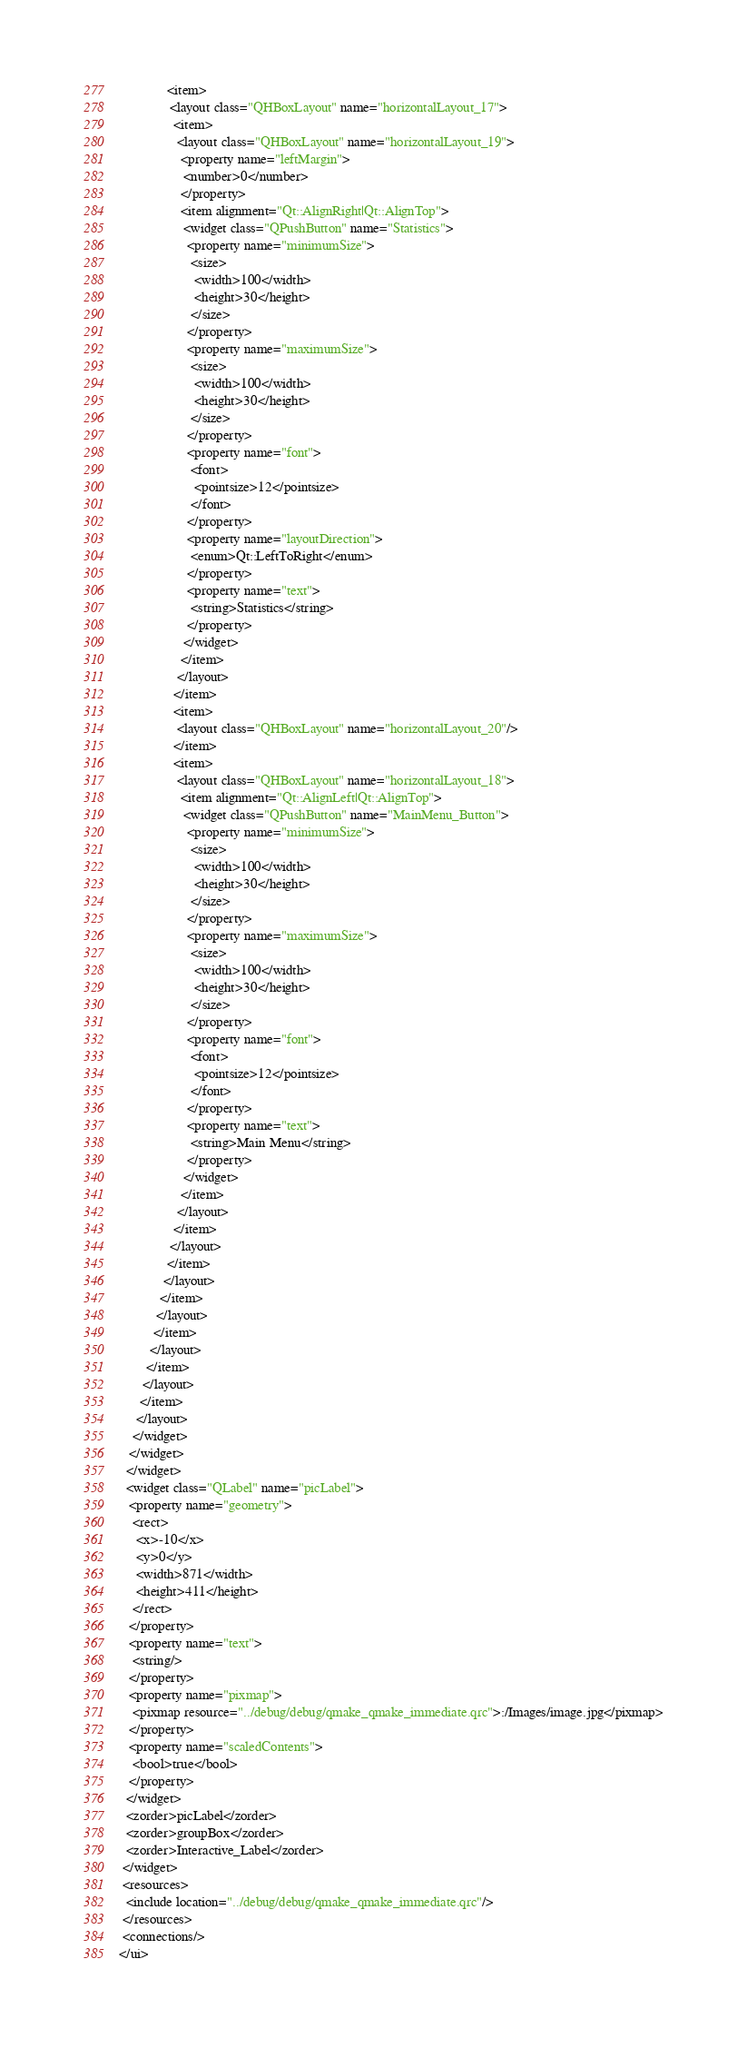Convert code to text. <code><loc_0><loc_0><loc_500><loc_500><_XML_>              <item>
               <layout class="QHBoxLayout" name="horizontalLayout_17">
                <item>
                 <layout class="QHBoxLayout" name="horizontalLayout_19">
                  <property name="leftMargin">
                   <number>0</number>
                  </property>
                  <item alignment="Qt::AlignRight|Qt::AlignTop">
                   <widget class="QPushButton" name="Statistics">
                    <property name="minimumSize">
                     <size>
                      <width>100</width>
                      <height>30</height>
                     </size>
                    </property>
                    <property name="maximumSize">
                     <size>
                      <width>100</width>
                      <height>30</height>
                     </size>
                    </property>
                    <property name="font">
                     <font>
                      <pointsize>12</pointsize>
                     </font>
                    </property>
                    <property name="layoutDirection">
                     <enum>Qt::LeftToRight</enum>
                    </property>
                    <property name="text">
                     <string>Statistics</string>
                    </property>
                   </widget>
                  </item>
                 </layout>
                </item>
                <item>
                 <layout class="QHBoxLayout" name="horizontalLayout_20"/>
                </item>
                <item>
                 <layout class="QHBoxLayout" name="horizontalLayout_18">
                  <item alignment="Qt::AlignLeft|Qt::AlignTop">
                   <widget class="QPushButton" name="MainMenu_Button">
                    <property name="minimumSize">
                     <size>
                      <width>100</width>
                      <height>30</height>
                     </size>
                    </property>
                    <property name="maximumSize">
                     <size>
                      <width>100</width>
                      <height>30</height>
                     </size>
                    </property>
                    <property name="font">
                     <font>
                      <pointsize>12</pointsize>
                     </font>
                    </property>
                    <property name="text">
                     <string>Main Menu</string>
                    </property>
                   </widget>
                  </item>
                 </layout>
                </item>
               </layout>
              </item>
             </layout>
            </item>
           </layout>
          </item>
         </layout>
        </item>
       </layout>
      </item>
     </layout>
    </widget>
   </widget>
  </widget>
  <widget class="QLabel" name="picLabel">
   <property name="geometry">
    <rect>
     <x>-10</x>
     <y>0</y>
     <width>871</width>
     <height>411</height>
    </rect>
   </property>
   <property name="text">
    <string/>
   </property>
   <property name="pixmap">
    <pixmap resource="../debug/debug/qmake_qmake_immediate.qrc">:/Images/image.jpg</pixmap>
   </property>
   <property name="scaledContents">
    <bool>true</bool>
   </property>
  </widget>
  <zorder>picLabel</zorder>
  <zorder>groupBox</zorder>
  <zorder>Interactive_Label</zorder>
 </widget>
 <resources>
  <include location="../debug/debug/qmake_qmake_immediate.qrc"/>
 </resources>
 <connections/>
</ui>
</code> 